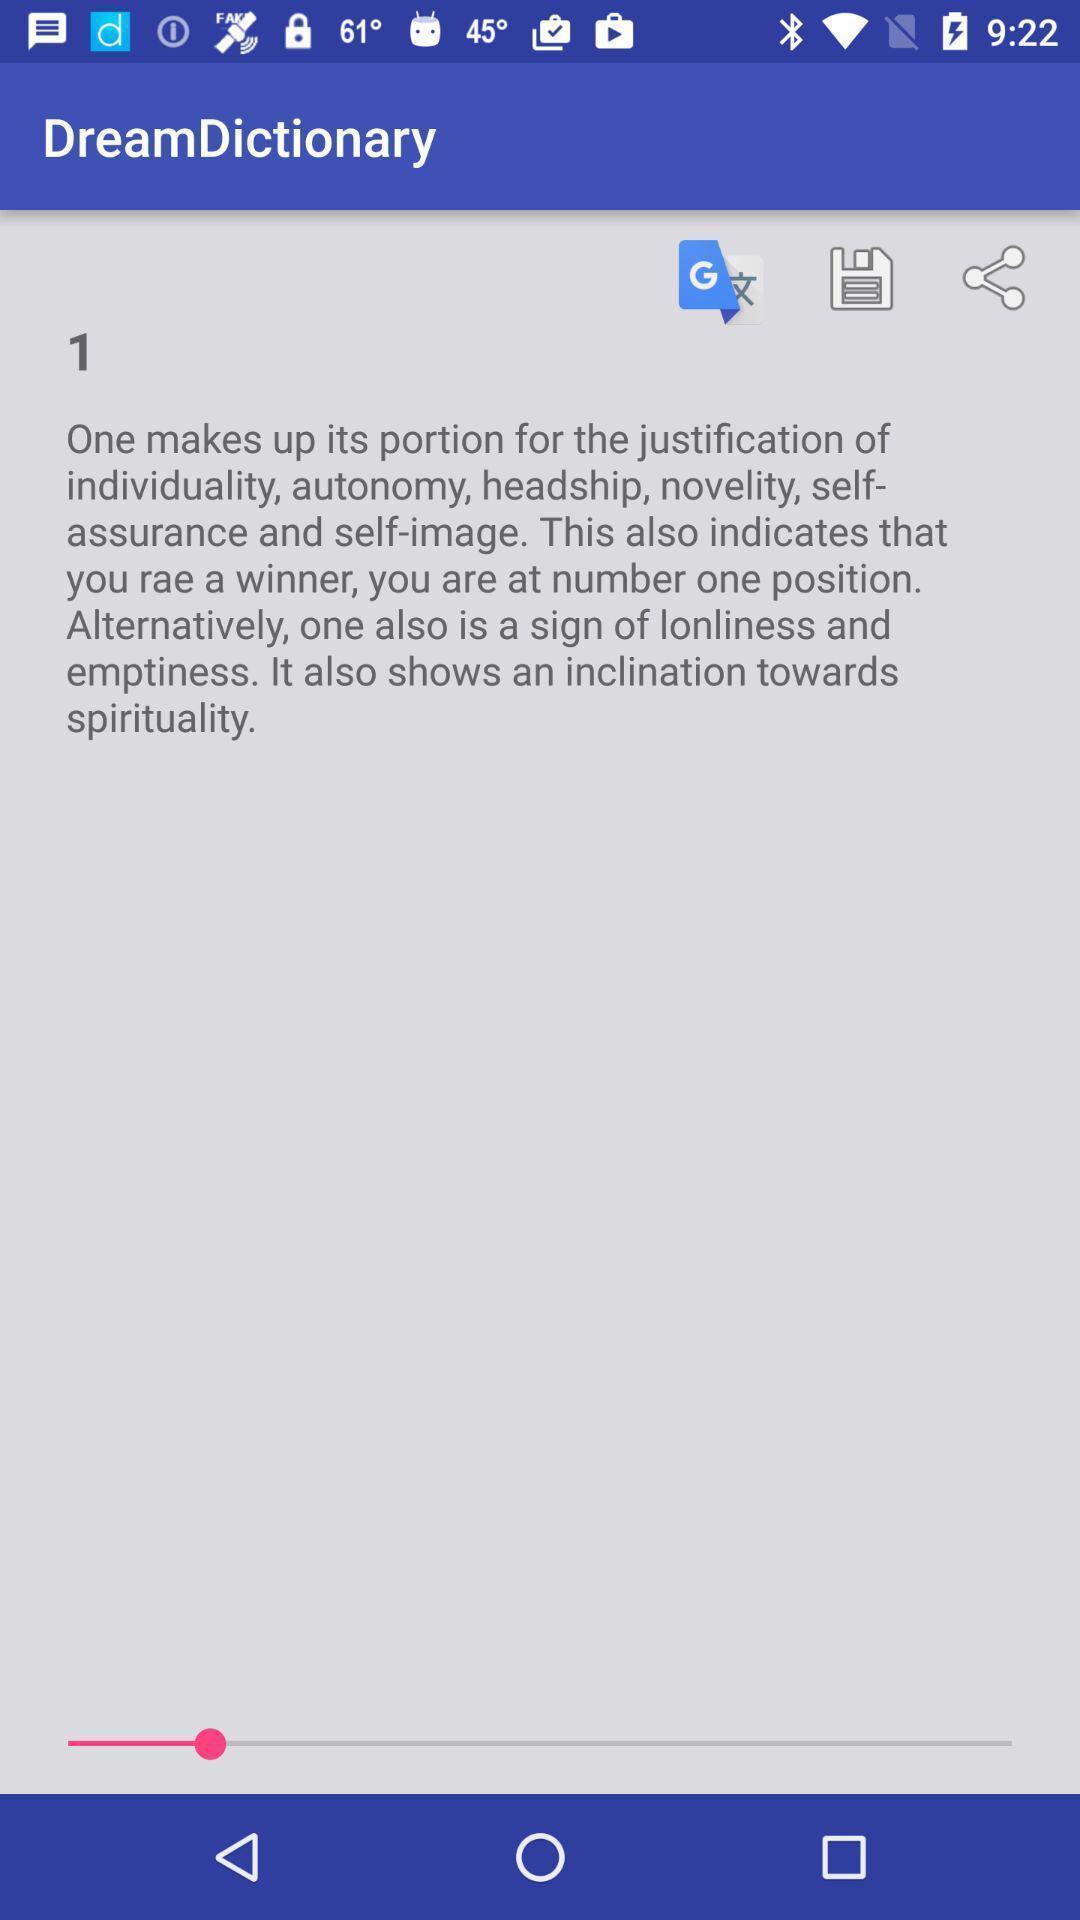Describe the content in this image. Screen showing page of an dictionary application. 